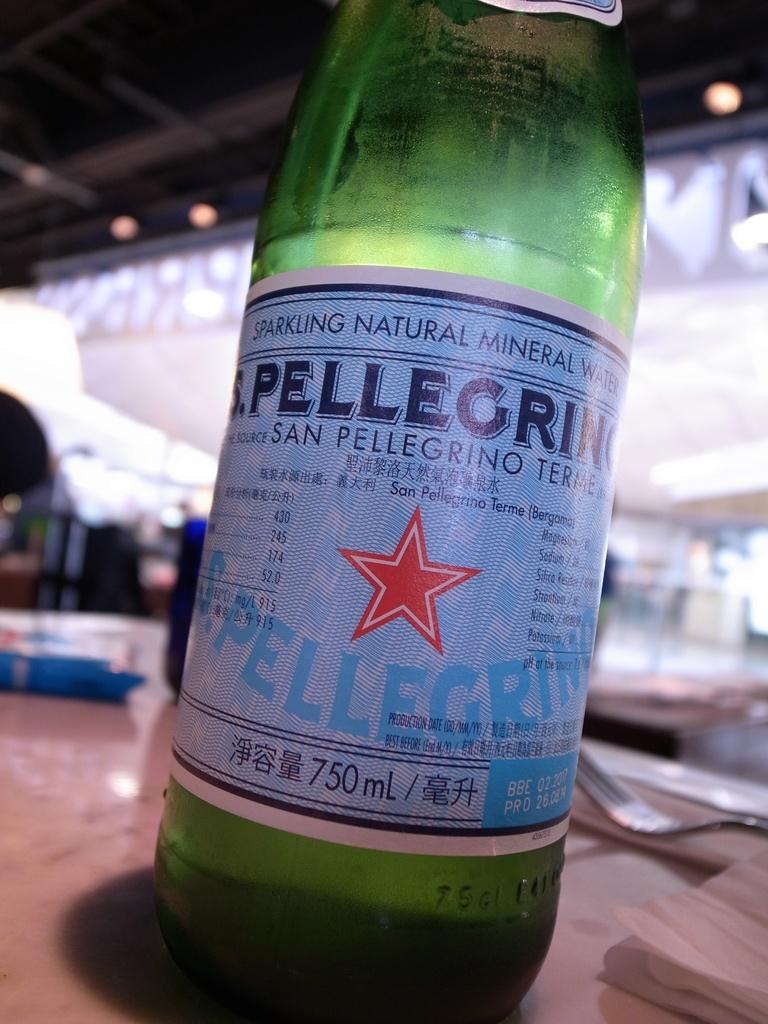Provide a one-sentence caption for the provided image. A bottle of Pellegrino water sits on a table. 